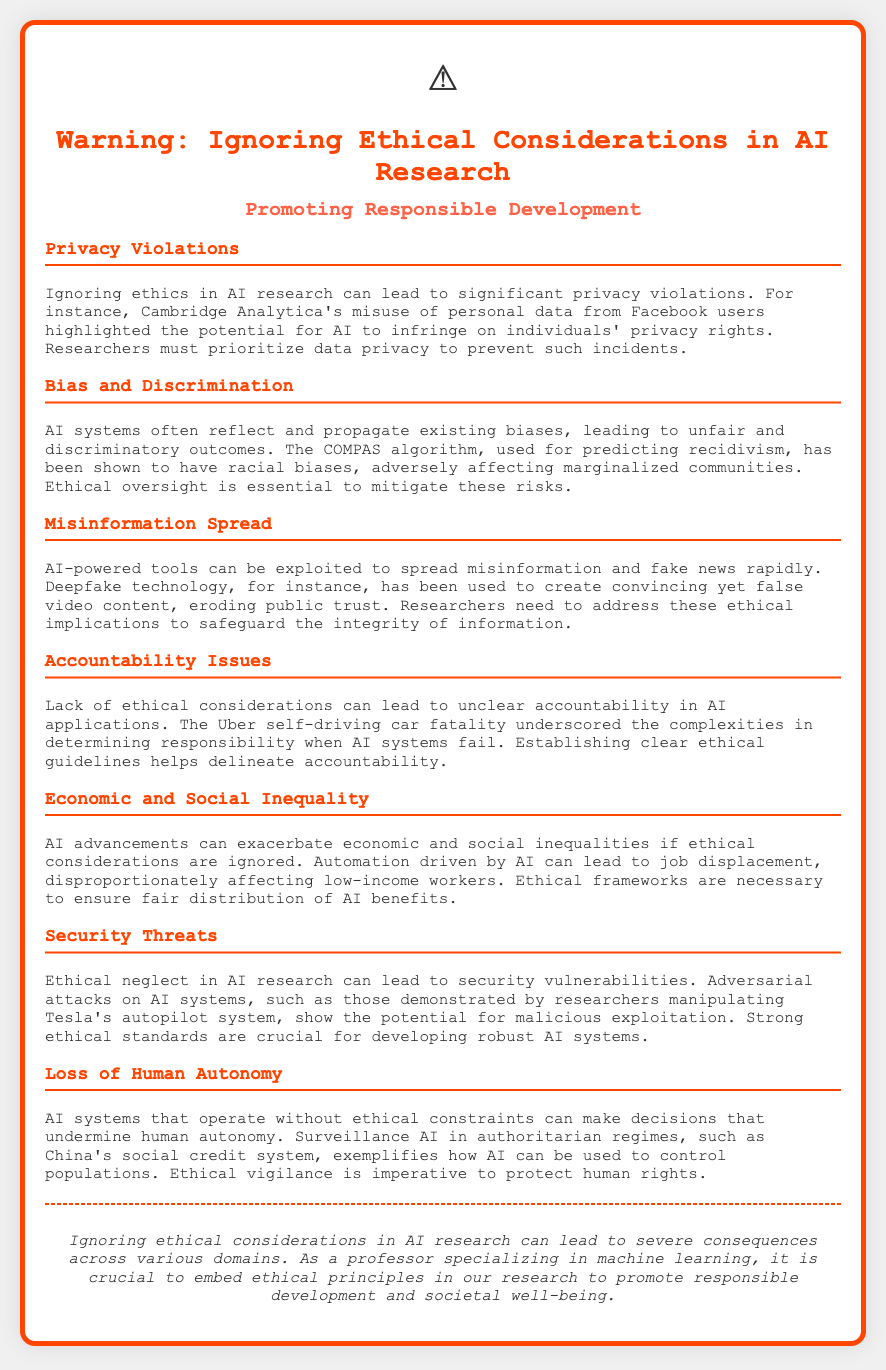What is the title of the document? The title of the document is explicitly mentioned in the header section, indicating the main focus on ethical considerations in AI.
Answer: Warning: Ignoring Ethical Considerations in AI Research What example of a privacy violation is mentioned? The document provides a specific instance where personal data was misused, highlighting its impact on privacy rights.
Answer: Cambridge Analytica Which algorithm is noted for demonstrating racial biases? This question pertains to a specific AI system used for prediction that has raised ethical concerns regarding bias.
Answer: COMPAS What is one potential consequence of ignoring ethics in AI regarding job displacement? The document outlines how AI advancements may lead to broader socio-economic issues, specifically related to employment.
Answer: Automation What security issue is highlighted in relation to ethical neglect in AI research? The text informs about particular vulnerabilities that arise when ethical considerations are not integrated into AI systems.
Answer: Adversarial attacks How does the document suggest ethical negligence affects accountability? This question references a significant incident to illustrate complexities in responsibility concerning AI system failures.
Answer: Uber self-driving car fatality What type of threats does the document associate with lack of ethical considerations? The response summarizes a broader concern raised about the implications when ethical principles are not followed in AI.
Answer: Security vulnerabilities What issue is raised about human autonomy? The document discusses a specific context where AI's operational lack of ethical constraints can undermine individual freedoms.
Answer: Surveillance AI in authoritarian regimes 